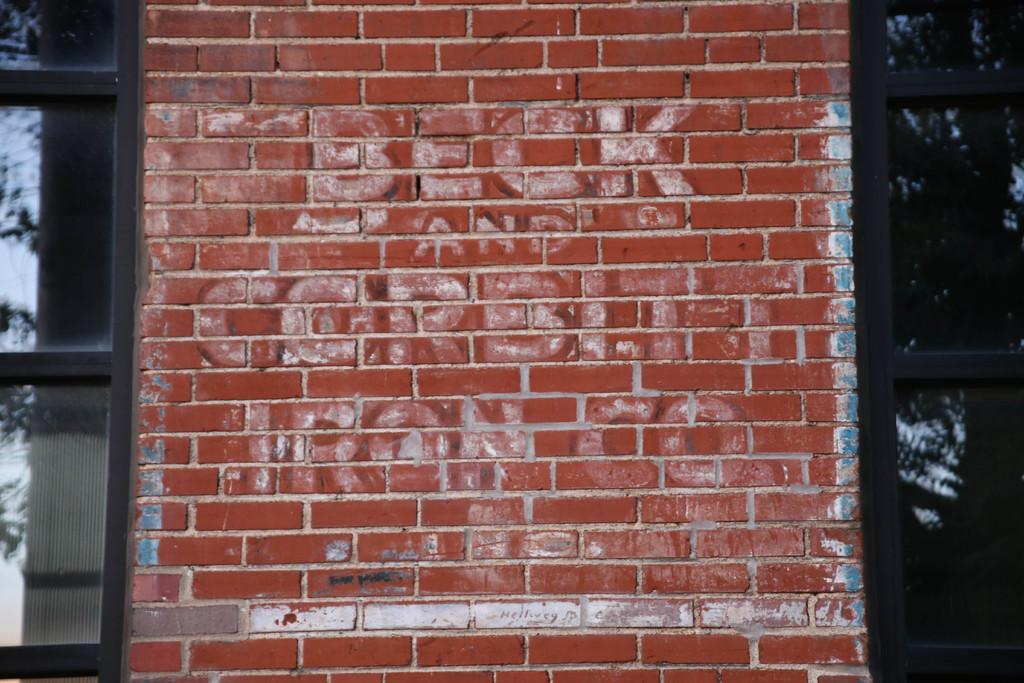What type of structure is visible in the image? There is a brick wall in the image. What is written or depicted on the brick wall? There is text on the brick wall. Are there any openings in the structure visible in the image? Yes, there are windows in the image. How many tomatoes are hanging from the windows in the image? There are no tomatoes visible in the image; it only features a brick wall with text and windows. 